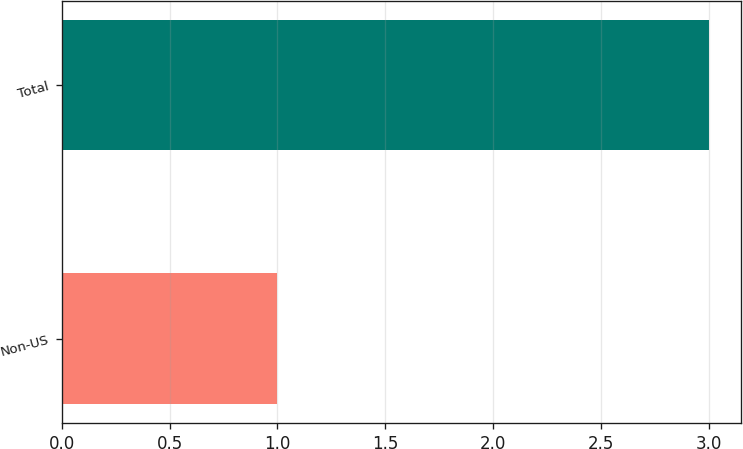<chart> <loc_0><loc_0><loc_500><loc_500><bar_chart><fcel>Non-US<fcel>Total<nl><fcel>1<fcel>3<nl></chart> 